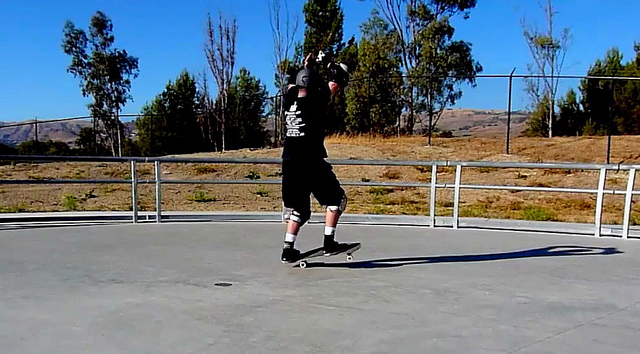Based on the photo, do you think the man is experienced in skateboarding? Based on the poised and controlled stance he maintains while performing the trick, it seems the man is likely experienced in skateboarding. The use of comprehensive safety gear and his confident posture both suggest he has spent considerable time honing his skills. What are some advanced skateboard tricks that experienced skaters perform? Experienced skateboarders often perform advanced tricks that require significant skill and practice. Some examples include:

1. **Tre Flip (360 Flip)**: An advanced trick combining a Kickflip with a backside 360 Pop Shove-it. This trick sends the skateboard spinning along both axes as the skater catches and lands it.

2. **Hardflip**: A complex trick that blends a Frontside Pop Shove-it with a Kickflip. The board spins down the middle as it flips.

3. **Laser Flip**: A tricky maneuver combining a 360 Heelflip with a Frontside 360 Shove-it. The board rotates fully while flipping along its axis.

4. **Backside Smith Grind**: This grind involves sliding the back truck on an edge while the front truck rises above it, demanding precision and balance.

5. **Inward Heelflip**: This involves a frontside Pop Shove-it combined with a Heelflip, flipping the board up and away behind the skater.

These advanced tricks demonstrate the complexities and impressive skill level achievable in skateboarding. 